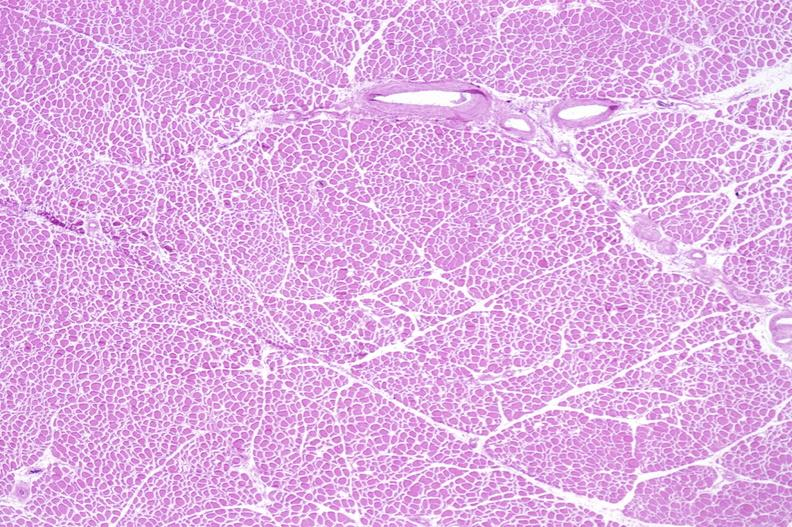does papillary adenoma show skeletal muscle atrophy?
Answer the question using a single word or phrase. No 